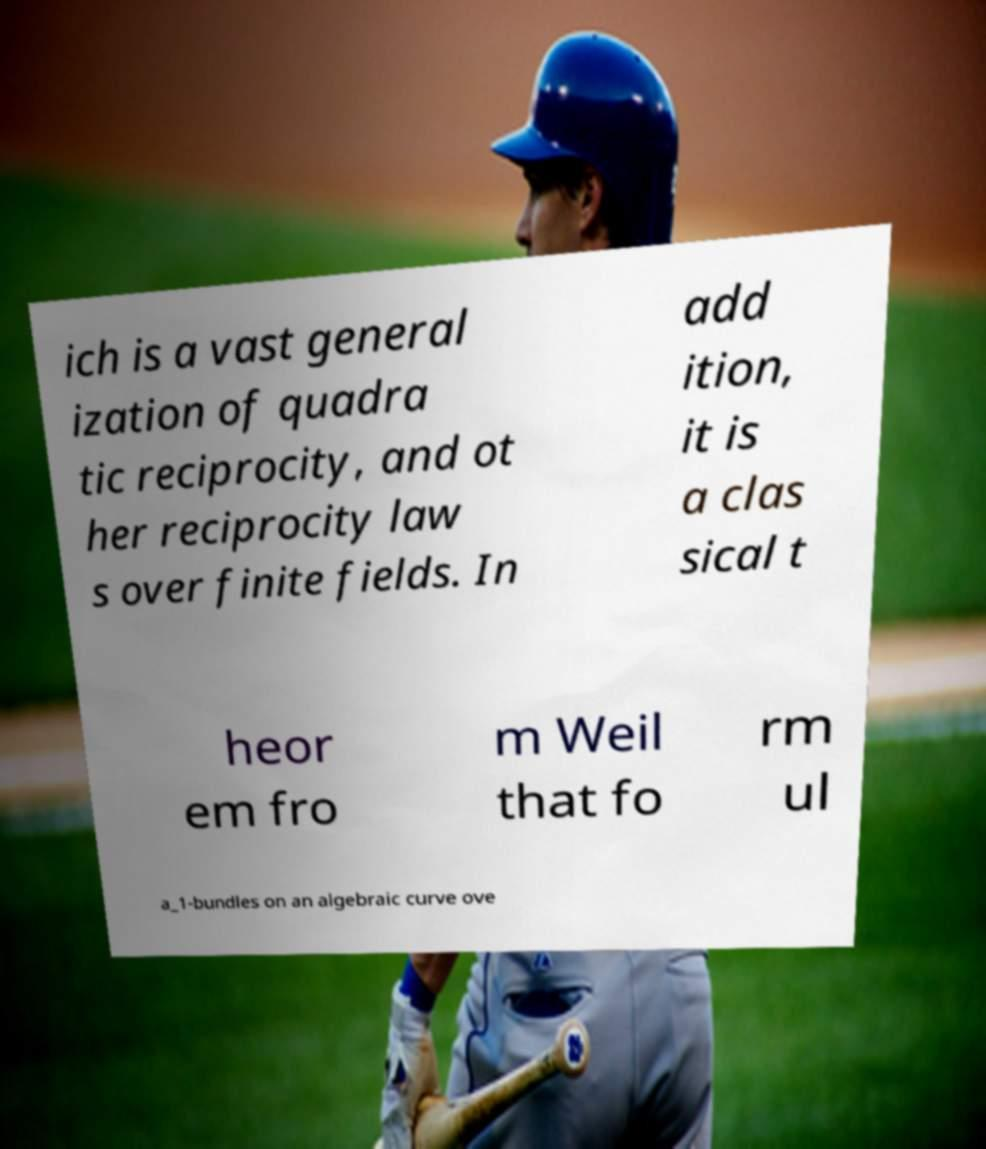For documentation purposes, I need the text within this image transcribed. Could you provide that? ich is a vast general ization of quadra tic reciprocity, and ot her reciprocity law s over finite fields. In add ition, it is a clas sical t heor em fro m Weil that fo rm ul a_1-bundles on an algebraic curve ove 